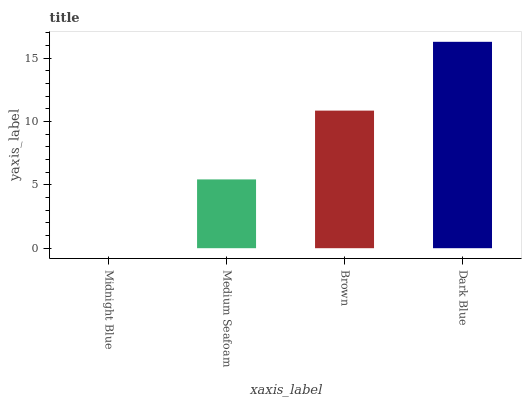Is Midnight Blue the minimum?
Answer yes or no. Yes. Is Dark Blue the maximum?
Answer yes or no. Yes. Is Medium Seafoam the minimum?
Answer yes or no. No. Is Medium Seafoam the maximum?
Answer yes or no. No. Is Medium Seafoam greater than Midnight Blue?
Answer yes or no. Yes. Is Midnight Blue less than Medium Seafoam?
Answer yes or no. Yes. Is Midnight Blue greater than Medium Seafoam?
Answer yes or no. No. Is Medium Seafoam less than Midnight Blue?
Answer yes or no. No. Is Brown the high median?
Answer yes or no. Yes. Is Medium Seafoam the low median?
Answer yes or no. Yes. Is Medium Seafoam the high median?
Answer yes or no. No. Is Dark Blue the low median?
Answer yes or no. No. 